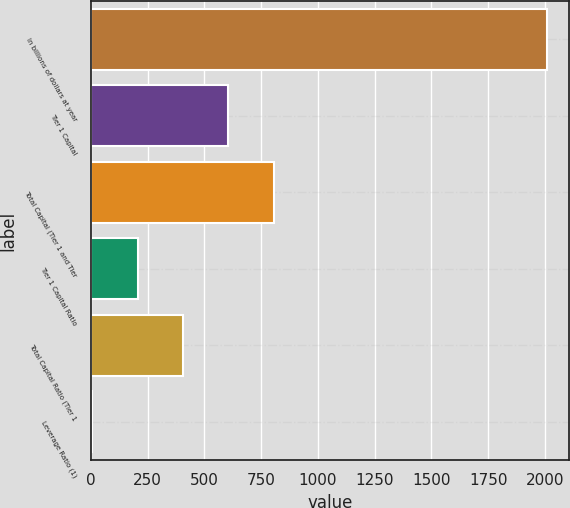Convert chart. <chart><loc_0><loc_0><loc_500><loc_500><bar_chart><fcel>In billions of dollars at year<fcel>Tier 1 Capital<fcel>Total Capital (Tier 1 and Tier<fcel>Tier 1 Capital Ratio<fcel>Total Capital Ratio (Tier 1<fcel>Leverage Ratio (1)<nl><fcel>2008<fcel>606.48<fcel>806.7<fcel>206.04<fcel>406.26<fcel>5.82<nl></chart> 